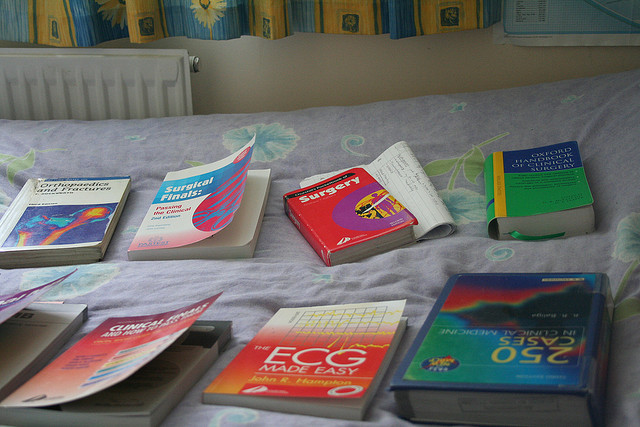Identify the text contained in this image. MADE Surgery Surgical Finalst MADE 250 CASES EASY CLINICAL 